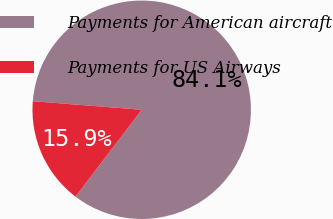<chart> <loc_0><loc_0><loc_500><loc_500><pie_chart><fcel>Payments for American aircraft<fcel>Payments for US Airways<nl><fcel>84.11%<fcel>15.89%<nl></chart> 